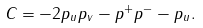Convert formula to latex. <formula><loc_0><loc_0><loc_500><loc_500>C = - 2 p _ { u } p _ { v } - p ^ { + } p ^ { - } - p _ { u } .</formula> 